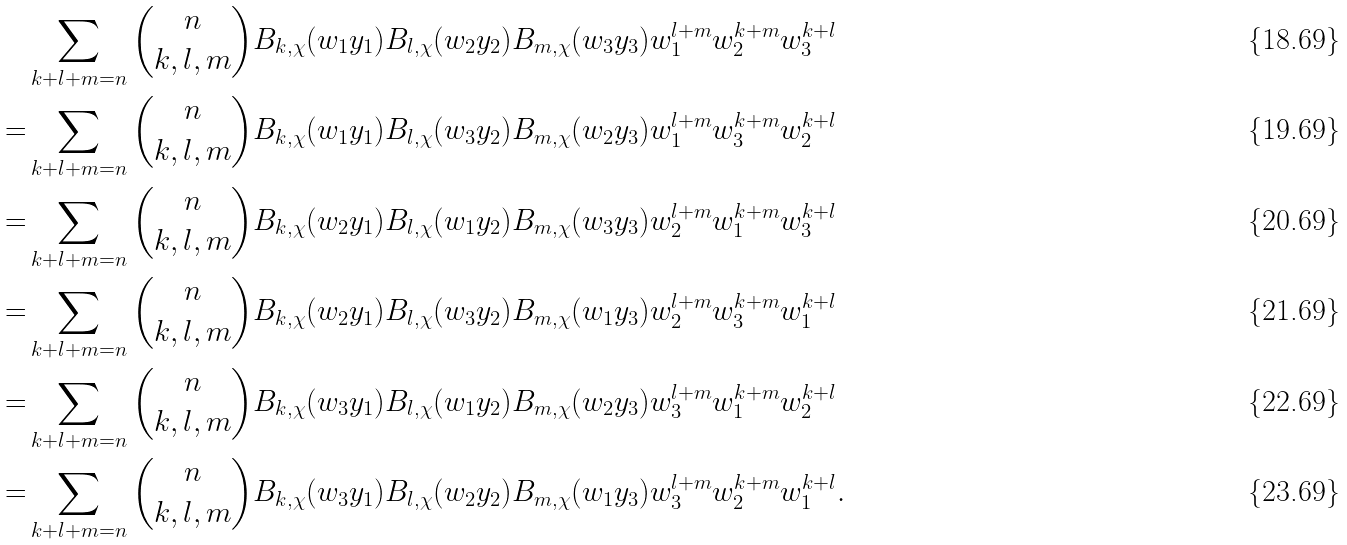<formula> <loc_0><loc_0><loc_500><loc_500>& \sum _ { k + l + m = n } \binom { n } { k , l , m } B _ { k , \chi } ( w _ { 1 } y _ { 1 } ) B _ { l , \chi } ( w _ { 2 } y _ { 2 } ) B _ { m , \chi } ( w _ { 3 } y _ { 3 } ) w _ { 1 } ^ { l + m } w _ { 2 } ^ { k + m } w _ { 3 } ^ { k + l } \\ = & \sum _ { k + l + m = n } \binom { n } { k , l , m } B _ { k , \chi } ( w _ { 1 } y _ { 1 } ) B _ { l , \chi } ( w _ { 3 } y _ { 2 } ) B _ { m , \chi } ( w _ { 2 } y _ { 3 } ) w _ { 1 } ^ { l + m } w _ { 3 } ^ { k + m } w _ { 2 } ^ { k + l } \\ = & \sum _ { k + l + m = n } \binom { n } { k , l , m } B _ { k , \chi } ( w _ { 2 } y _ { 1 } ) B _ { l , \chi } ( w _ { 1 } y _ { 2 } ) B _ { m , \chi } ( w _ { 3 } y _ { 3 } ) w _ { 2 } ^ { l + m } w _ { 1 } ^ { k + m } w _ { 3 } ^ { k + l } \\ = & \sum _ { k + l + m = n } \binom { n } { k , l , m } B _ { k , \chi } ( w _ { 2 } y _ { 1 } ) B _ { l , \chi } ( w _ { 3 } y _ { 2 } ) B _ { m , \chi } ( w _ { 1 } y _ { 3 } ) w _ { 2 } ^ { l + m } w _ { 3 } ^ { k + m } w _ { 1 } ^ { k + l } \\ = & \sum _ { k + l + m = n } \binom { n } { k , l , m } B _ { k , \chi } ( w _ { 3 } y _ { 1 } ) B _ { l , \chi } ( w _ { 1 } y _ { 2 } ) B _ { m , \chi } ( w _ { 2 } y _ { 3 } ) w _ { 3 } ^ { l + m } w _ { 1 } ^ { k + m } w _ { 2 } ^ { k + l } \\ = & \sum _ { k + l + m = n } \binom { n } { k , l , m } B _ { k , \chi } ( w _ { 3 } y _ { 1 } ) B _ { l , \chi } ( w _ { 2 } y _ { 2 } ) B _ { m , \chi } ( w _ { 1 } y _ { 3 } ) w _ { 3 } ^ { l + m } w _ { 2 } ^ { k + m } w _ { 1 } ^ { k + l } .</formula> 